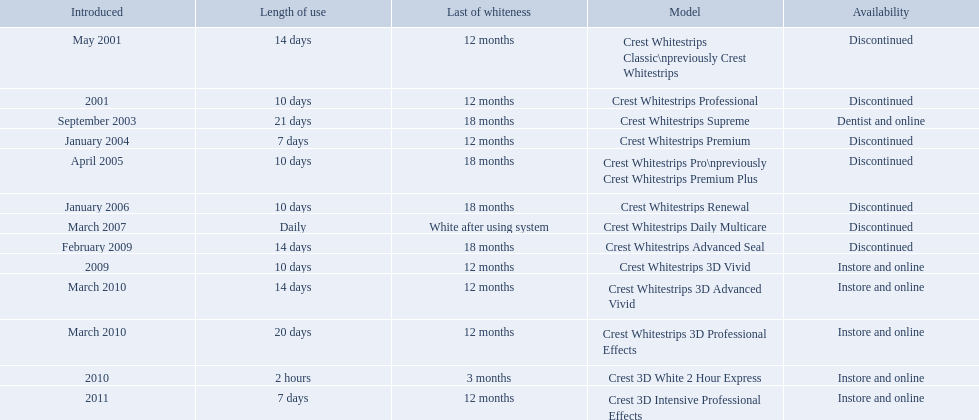What are all of the model names? Crest Whitestrips Classic\npreviously Crest Whitestrips, Crest Whitestrips Professional, Crest Whitestrips Supreme, Crest Whitestrips Premium, Crest Whitestrips Pro\npreviously Crest Whitestrips Premium Plus, Crest Whitestrips Renewal, Crest Whitestrips Daily Multicare, Crest Whitestrips Advanced Seal, Crest Whitestrips 3D Vivid, Crest Whitestrips 3D Advanced Vivid, Crest Whitestrips 3D Professional Effects, Crest 3D White 2 Hour Express, Crest 3D Intensive Professional Effects. When were they first introduced? May 2001, 2001, September 2003, January 2004, April 2005, January 2006, March 2007, February 2009, 2009, March 2010, March 2010, 2010, 2011. Along with crest whitestrips 3d advanced vivid, which other model was introduced in march 2010? Crest Whitestrips 3D Professional Effects. 